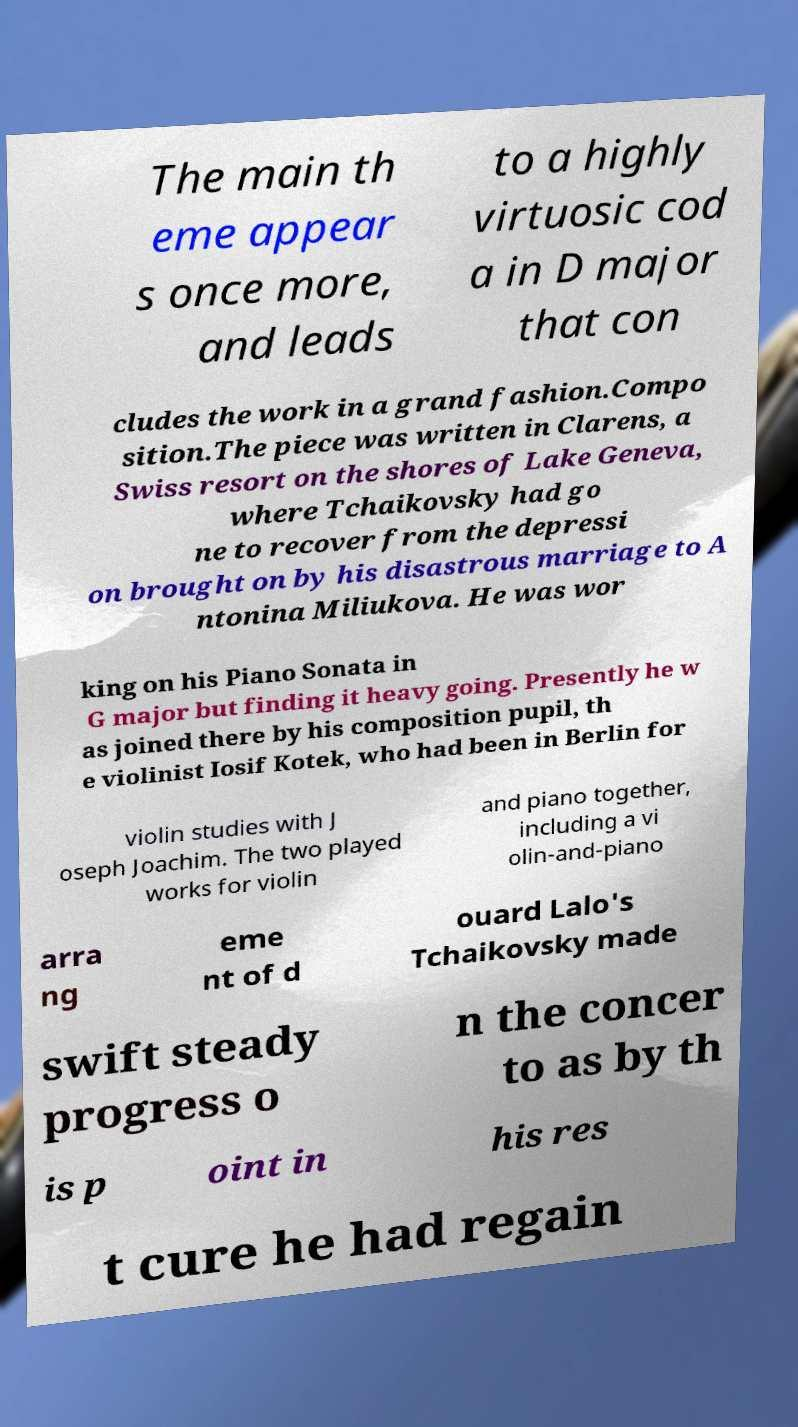Please identify and transcribe the text found in this image. The main th eme appear s once more, and leads to a highly virtuosic cod a in D major that con cludes the work in a grand fashion.Compo sition.The piece was written in Clarens, a Swiss resort on the shores of Lake Geneva, where Tchaikovsky had go ne to recover from the depressi on brought on by his disastrous marriage to A ntonina Miliukova. He was wor king on his Piano Sonata in G major but finding it heavy going. Presently he w as joined there by his composition pupil, th e violinist Iosif Kotek, who had been in Berlin for violin studies with J oseph Joachim. The two played works for violin and piano together, including a vi olin-and-piano arra ng eme nt of d ouard Lalo's Tchaikovsky made swift steady progress o n the concer to as by th is p oint in his res t cure he had regain 